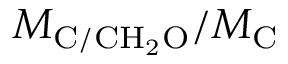Convert formula to latex. <formula><loc_0><loc_0><loc_500><loc_500>M _ { C / C H _ { 2 } O } / M _ { C }</formula> 